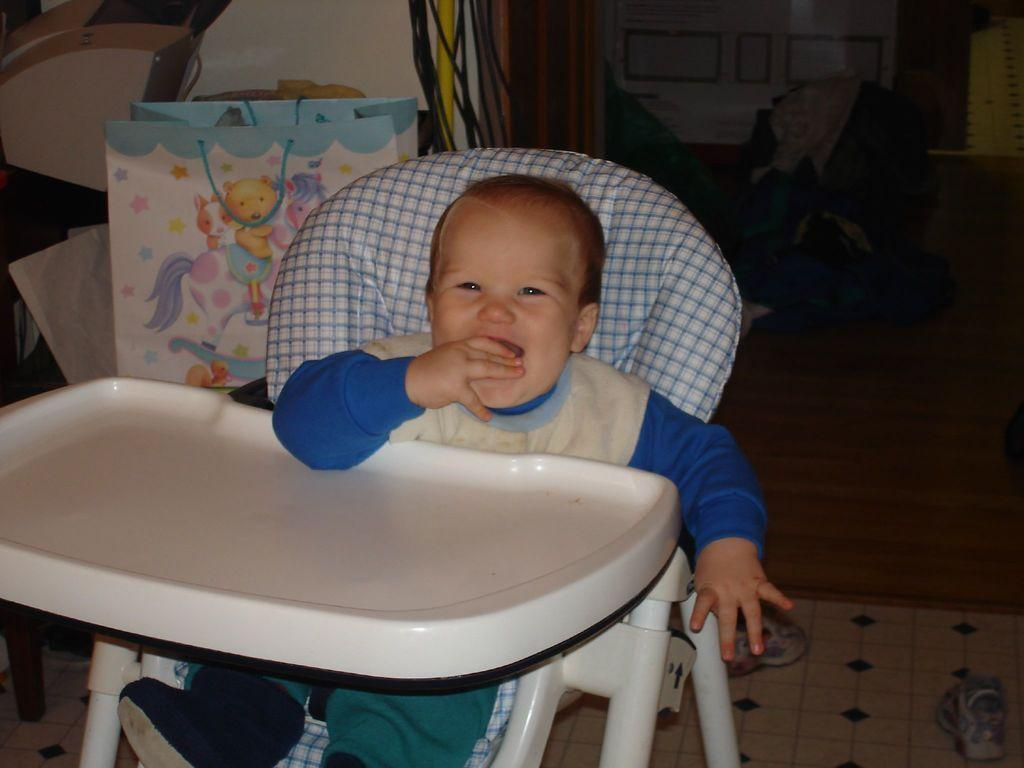What is the main subject of the image? There is a baby in the image. What is the baby doing in the image? The baby is sitting on a chair. What can be seen in the background of the image? There is a floor, a wall, wires, and a bag visible in the background of the image. What type of bell can be heard ringing in the image? There is no bell present in the image, and therefore no sound can be heard. 